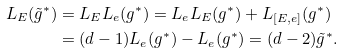Convert formula to latex. <formula><loc_0><loc_0><loc_500><loc_500>L _ { E } ( \tilde { g } ^ { * } ) & = L _ { E } L _ { e } ( g ^ { * } ) = L _ { e } L _ { E } ( g ^ { * } ) + L _ { [ E , e ] } ( g ^ { * } ) \\ & = ( d - 1 ) L _ { e } ( g ^ { * } ) - L _ { e } ( g ^ { * } ) = ( d - 2 ) \tilde { g } ^ { * } .</formula> 